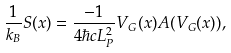Convert formula to latex. <formula><loc_0><loc_0><loc_500><loc_500>\frac { 1 } { k _ { B } } S ( x ) = \frac { - 1 } { 4 \hbar { c } L _ { P } ^ { 2 } } V _ { G } ( x ) A ( V _ { G } ( x ) ) ,</formula> 